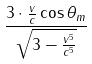<formula> <loc_0><loc_0><loc_500><loc_500>\frac { 3 \cdot \frac { v } { c } \cos \theta _ { m } } { \sqrt { 3 - \frac { v ^ { 5 } } { c ^ { 5 } } } }</formula> 